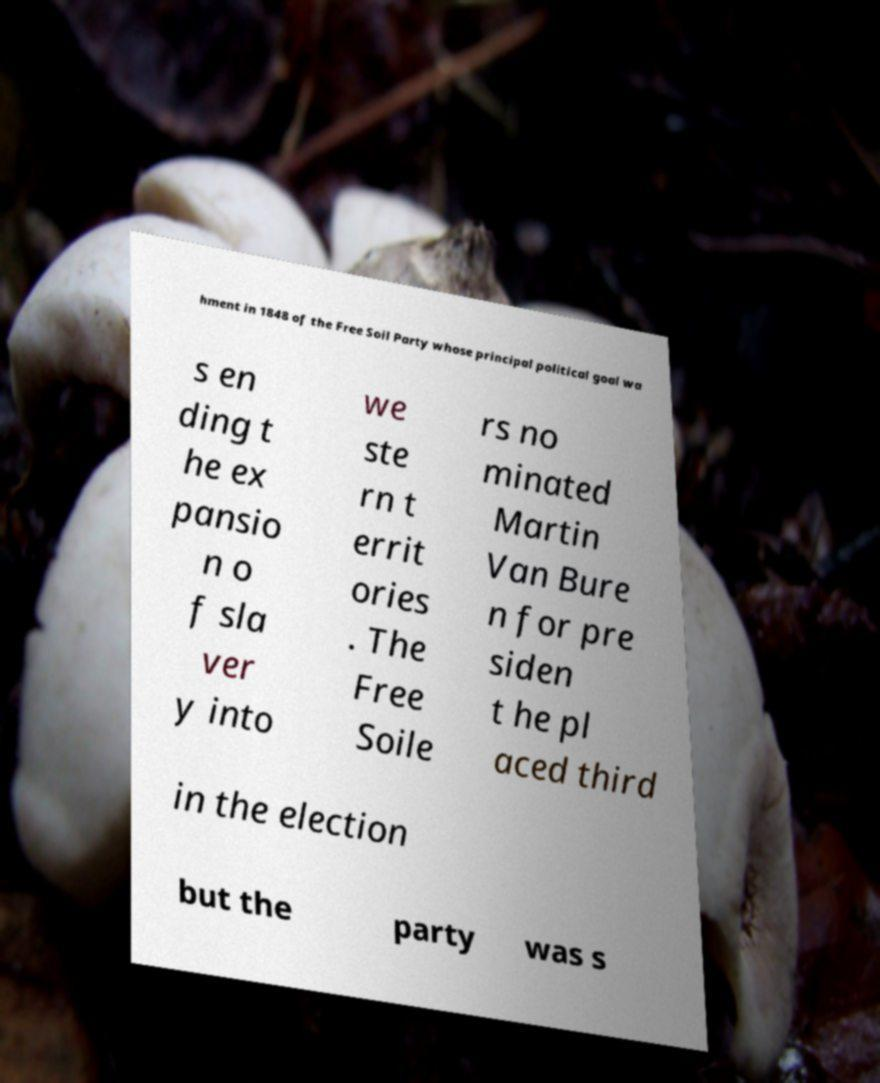Can you accurately transcribe the text from the provided image for me? hment in 1848 of the Free Soil Party whose principal political goal wa s en ding t he ex pansio n o f sla ver y into we ste rn t errit ories . The Free Soile rs no minated Martin Van Bure n for pre siden t he pl aced third in the election but the party was s 